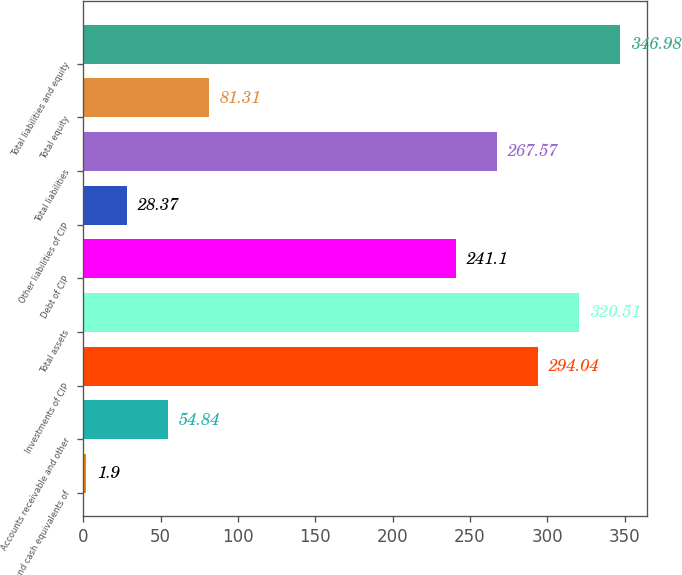<chart> <loc_0><loc_0><loc_500><loc_500><bar_chart><fcel>Cash and cash equivalents of<fcel>Accounts receivable and other<fcel>Investments of CIP<fcel>Total assets<fcel>Debt of CIP<fcel>Other liabilities of CIP<fcel>Total liabilities<fcel>Total equity<fcel>Total liabilities and equity<nl><fcel>1.9<fcel>54.84<fcel>294.04<fcel>320.51<fcel>241.1<fcel>28.37<fcel>267.57<fcel>81.31<fcel>346.98<nl></chart> 